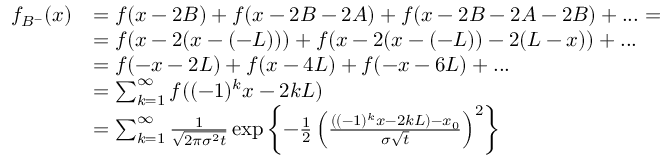Convert formula to latex. <formula><loc_0><loc_0><loc_500><loc_500>\begin{array} { r l } { f _ { B ^ { - } } ( x ) } & { = f ( x - 2 B ) + f ( x - 2 B - 2 A ) + f ( x - 2 B - 2 A - 2 B ) + \dots = } \\ & { = f ( x - 2 ( x - ( - L ) ) ) + f ( x - 2 ( x - ( - L ) ) - 2 ( L - x ) ) + \dots } \\ & { = f ( - x - 2 L ) + f ( x - 4 L ) + f ( - x - 6 L ) + \dots } \\ & { = \sum _ { k = 1 } ^ { \infty } f ( ( - 1 ) ^ { k } x - 2 k L ) } \\ & { = \sum _ { k = 1 } ^ { \infty } \frac { 1 } { \sqrt { 2 \pi \sigma ^ { 2 } t } } \exp \left \{ - \frac { 1 } { 2 } \left ( \frac { ( ( - 1 ) ^ { k } x - 2 k L ) - x _ { 0 } } { \sigma \sqrt { t } } \right ) ^ { 2 } \right \} } \end{array}</formula> 